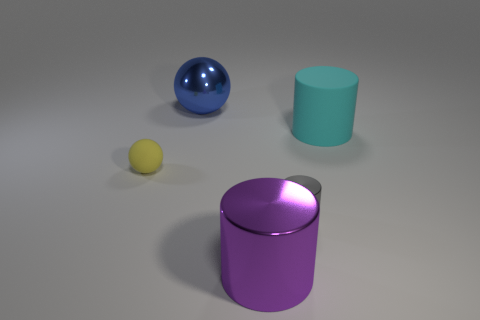What number of things are either small rubber things or objects behind the large metallic cylinder?
Your response must be concise. 4. What number of other things are there of the same size as the cyan rubber cylinder?
Provide a succinct answer. 2. Does the sphere that is in front of the blue shiny thing have the same material as the ball that is behind the tiny yellow thing?
Your response must be concise. No. How many gray things are on the right side of the tiny cylinder?
Give a very brief answer. 0. What number of green objects are either tiny metal cylinders or large metallic cubes?
Offer a very short reply. 0. There is a purple object that is the same size as the blue sphere; what material is it?
Your answer should be compact. Metal. What is the shape of the big thing that is both behind the yellow matte ball and to the left of the large cyan rubber thing?
Keep it short and to the point. Sphere. What is the color of the cylinder that is the same size as the cyan thing?
Ensure brevity in your answer.  Purple. Is the size of the matte object right of the large blue thing the same as the metallic object behind the small rubber object?
Ensure brevity in your answer.  Yes. There is a metal object right of the large metallic object that is in front of the matte thing to the left of the cyan rubber object; what size is it?
Provide a short and direct response. Small. 